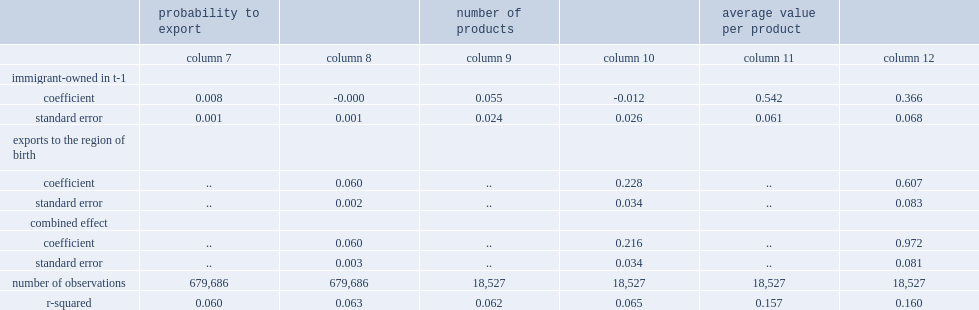How many percentage points are immigrant-owned wholesalers more likely to export than their canadian-owned counterparts, regardless of export destination? 0.008. How many percentage points are immigrant-owned wholesalers more likely to export to immigrant owners' regions of origin than canadian-owned wholesalers? 0.06. What the percentage did immigrant-owned exporters export slightly more products, regardless of destination,compared with canadian-owned exporters in the wholesale trade sector. 0.055. What the percentage did immigrant-owned exporters export more products to their owners' regions of origin? 0.024. 